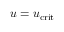<formula> <loc_0><loc_0><loc_500><loc_500>u = u _ { c r i t }</formula> 